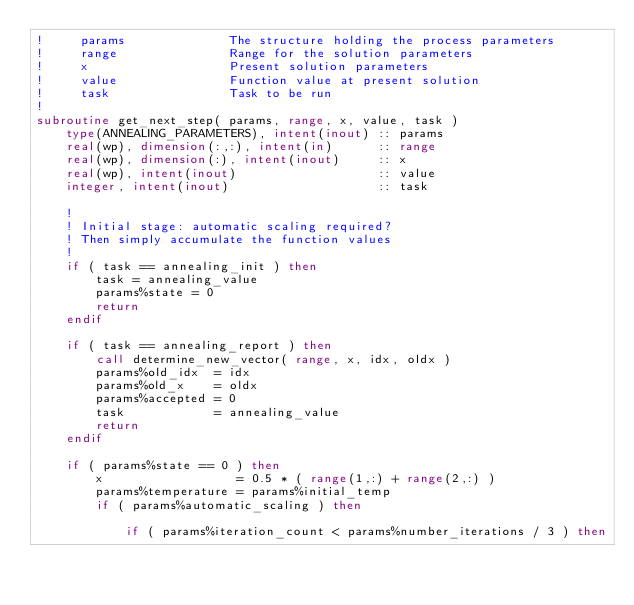<code> <loc_0><loc_0><loc_500><loc_500><_FORTRAN_>!     params              The structure holding the process parameters
!     range               Range for the solution parameters
!     x                   Present solution parameters
!     value               Function value at present solution
!     task                Task to be run
!
subroutine get_next_step( params, range, x, value, task )
    type(ANNEALING_PARAMETERS), intent(inout) :: params
    real(wp), dimension(:,:), intent(in)      :: range
    real(wp), dimension(:), intent(inout)     :: x
    real(wp), intent(inout)                   :: value
    integer, intent(inout)                    :: task

    !
    ! Initial stage: automatic scaling required?
    ! Then simply accumulate the function values
    !
    if ( task == annealing_init ) then
        task = annealing_value
        params%state = 0
        return
    endif

    if ( task == annealing_report ) then
        call determine_new_vector( range, x, idx, oldx )
        params%old_idx  = idx
        params%old_x    = oldx
        params%accepted = 0
        task            = annealing_value
        return
    endif

    if ( params%state == 0 ) then
        x                  = 0.5 * ( range(1,:) + range(2,:) )
        params%temperature = params%initial_temp
        if ( params%automatic_scaling ) then

            if ( params%iteration_count < params%number_iterations / 3 ) then</code> 